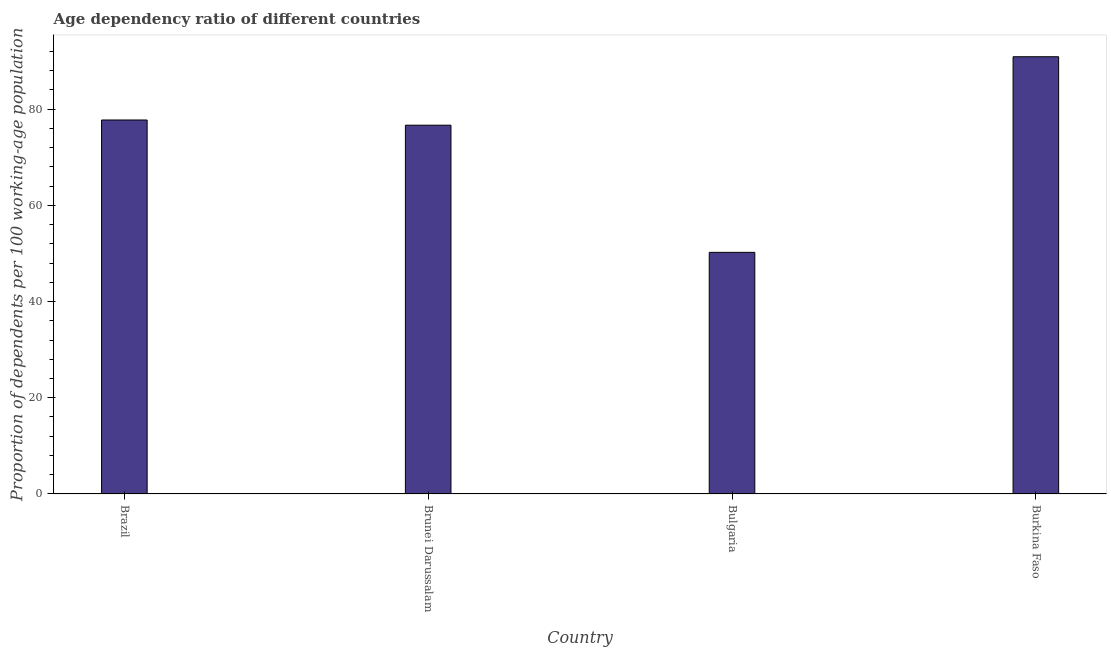Does the graph contain any zero values?
Give a very brief answer. No. What is the title of the graph?
Ensure brevity in your answer.  Age dependency ratio of different countries. What is the label or title of the X-axis?
Provide a succinct answer. Country. What is the label or title of the Y-axis?
Provide a short and direct response. Proportion of dependents per 100 working-age population. What is the age dependency ratio in Brunei Darussalam?
Your response must be concise. 76.64. Across all countries, what is the maximum age dependency ratio?
Provide a short and direct response. 90.87. Across all countries, what is the minimum age dependency ratio?
Provide a succinct answer. 50.22. In which country was the age dependency ratio maximum?
Your answer should be compact. Burkina Faso. In which country was the age dependency ratio minimum?
Provide a succinct answer. Bulgaria. What is the sum of the age dependency ratio?
Ensure brevity in your answer.  295.46. What is the difference between the age dependency ratio in Bulgaria and Burkina Faso?
Make the answer very short. -40.66. What is the average age dependency ratio per country?
Make the answer very short. 73.86. What is the median age dependency ratio?
Make the answer very short. 77.18. What is the ratio of the age dependency ratio in Brazil to that in Brunei Darussalam?
Make the answer very short. 1.01. Is the age dependency ratio in Brazil less than that in Burkina Faso?
Give a very brief answer. Yes. Is the difference between the age dependency ratio in Brazil and Bulgaria greater than the difference between any two countries?
Offer a very short reply. No. What is the difference between the highest and the second highest age dependency ratio?
Offer a terse response. 13.15. Is the sum of the age dependency ratio in Brazil and Burkina Faso greater than the maximum age dependency ratio across all countries?
Your answer should be compact. Yes. What is the difference between the highest and the lowest age dependency ratio?
Your response must be concise. 40.65. In how many countries, is the age dependency ratio greater than the average age dependency ratio taken over all countries?
Your answer should be compact. 3. Are all the bars in the graph horizontal?
Your response must be concise. No. What is the difference between two consecutive major ticks on the Y-axis?
Your answer should be very brief. 20. Are the values on the major ticks of Y-axis written in scientific E-notation?
Provide a short and direct response. No. What is the Proportion of dependents per 100 working-age population of Brazil?
Give a very brief answer. 77.73. What is the Proportion of dependents per 100 working-age population of Brunei Darussalam?
Provide a short and direct response. 76.64. What is the Proportion of dependents per 100 working-age population in Bulgaria?
Make the answer very short. 50.22. What is the Proportion of dependents per 100 working-age population of Burkina Faso?
Your answer should be compact. 90.87. What is the difference between the Proportion of dependents per 100 working-age population in Brazil and Brunei Darussalam?
Give a very brief answer. 1.08. What is the difference between the Proportion of dependents per 100 working-age population in Brazil and Bulgaria?
Offer a very short reply. 27.51. What is the difference between the Proportion of dependents per 100 working-age population in Brazil and Burkina Faso?
Make the answer very short. -13.15. What is the difference between the Proportion of dependents per 100 working-age population in Brunei Darussalam and Bulgaria?
Keep it short and to the point. 26.43. What is the difference between the Proportion of dependents per 100 working-age population in Brunei Darussalam and Burkina Faso?
Give a very brief answer. -14.23. What is the difference between the Proportion of dependents per 100 working-age population in Bulgaria and Burkina Faso?
Ensure brevity in your answer.  -40.65. What is the ratio of the Proportion of dependents per 100 working-age population in Brazil to that in Bulgaria?
Offer a terse response. 1.55. What is the ratio of the Proportion of dependents per 100 working-age population in Brazil to that in Burkina Faso?
Offer a very short reply. 0.85. What is the ratio of the Proportion of dependents per 100 working-age population in Brunei Darussalam to that in Bulgaria?
Your response must be concise. 1.53. What is the ratio of the Proportion of dependents per 100 working-age population in Brunei Darussalam to that in Burkina Faso?
Your response must be concise. 0.84. What is the ratio of the Proportion of dependents per 100 working-age population in Bulgaria to that in Burkina Faso?
Make the answer very short. 0.55. 